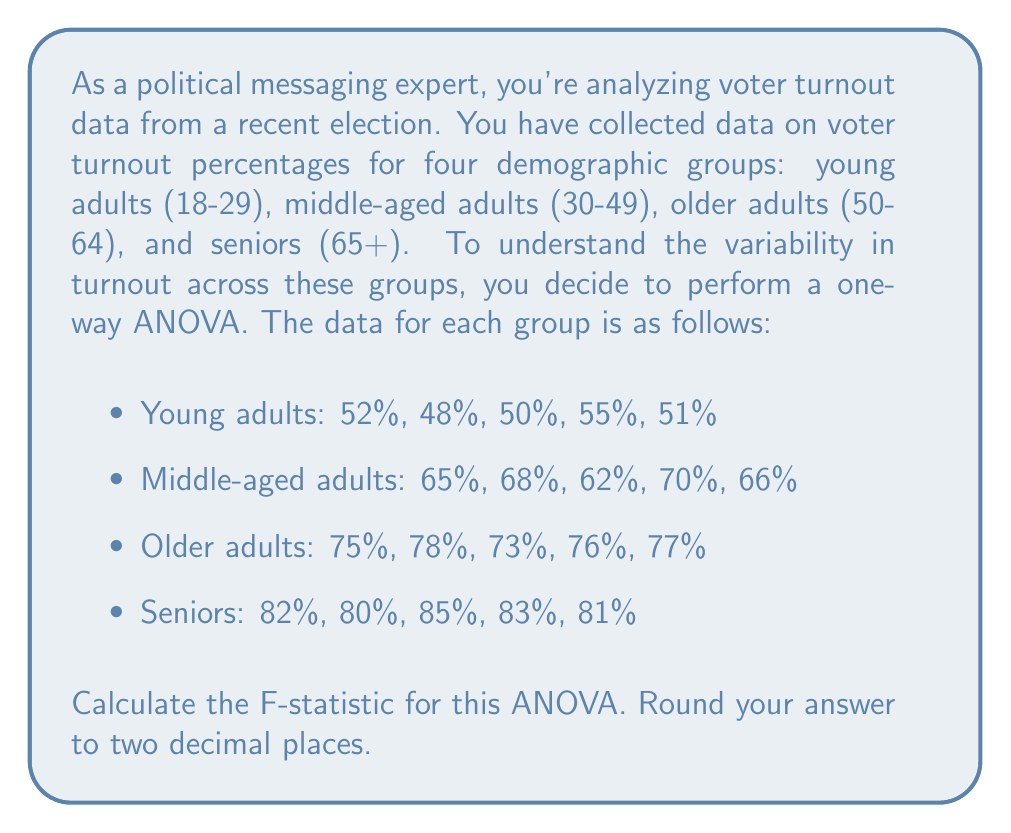Help me with this question. To calculate the F-statistic for a one-way ANOVA, we need to follow these steps:

1. Calculate the overall mean:
$$\bar{X} = \frac{\sum_{i=1}^{n} X_i}{n} = \frac{1374}{20} = 68.7\%$$

2. Calculate the between-group sum of squares (SSB):
$$SSB = \sum_{i=1}^{k} n_i(\bar{X_i} - \bar{X})^2$$
Where $k$ is the number of groups, $n_i$ is the number of observations in each group, and $\bar{X_i}$ is the mean of each group.

Young adults: $\bar{X_1} = 51.2\%$
Middle-aged adults: $\bar{X_2} = 66.2\%$
Older adults: $\bar{X_3} = 75.8\%$
Seniors: $\bar{X_4} = 82.2\%$

$$SSB = 5(51.2 - 68.7)^2 + 5(66.2 - 68.7)^2 + 5(75.8 - 68.7)^2 + 5(82.2 - 68.7)^2 = 3,843.78$$

3. Calculate the within-group sum of squares (SSW):
$$SSW = \sum_{i=1}^{k} \sum_{j=1}^{n_i} (X_{ij} - \bar{X_i})^2$$

Young adults: $52^2 + 48^2 + 50^2 + 55^2 + 51^2 - 5(51.2)^2 = 29.8$
Middle-aged adults: $65^2 + 68^2 + 62^2 + 70^2 + 66^2 - 5(66.2)^2 = 39.8$
Older adults: $75^2 + 78^2 + 73^2 + 76^2 + 77^2 - 5(75.8)^2 = 14.8$
Seniors: $82^2 + 80^2 + 85^2 + 83^2 + 81^2 - 5(82.2)^2 = 17.8$

$$SSW = 29.8 + 39.8 + 14.8 + 17.8 = 102.2$$

4. Calculate the degrees of freedom:
Between-group df: $df_B = k - 1 = 4 - 1 = 3$
Within-group df: $df_W = n - k = 20 - 4 = 16$

5. Calculate the mean square between (MSB) and mean square within (MSW):
$$MSB = \frac{SSB}{df_B} = \frac{3,843.78}{3} = 1,281.26$$
$$MSW = \frac{SSW}{df_W} = \frac{102.2}{16} = 6.3875$$

6. Calculate the F-statistic:
$$F = \frac{MSB}{MSW} = \frac{1,281.26}{6.3875} = 200.59$$
Answer: The F-statistic for this ANOVA is 200.59. 